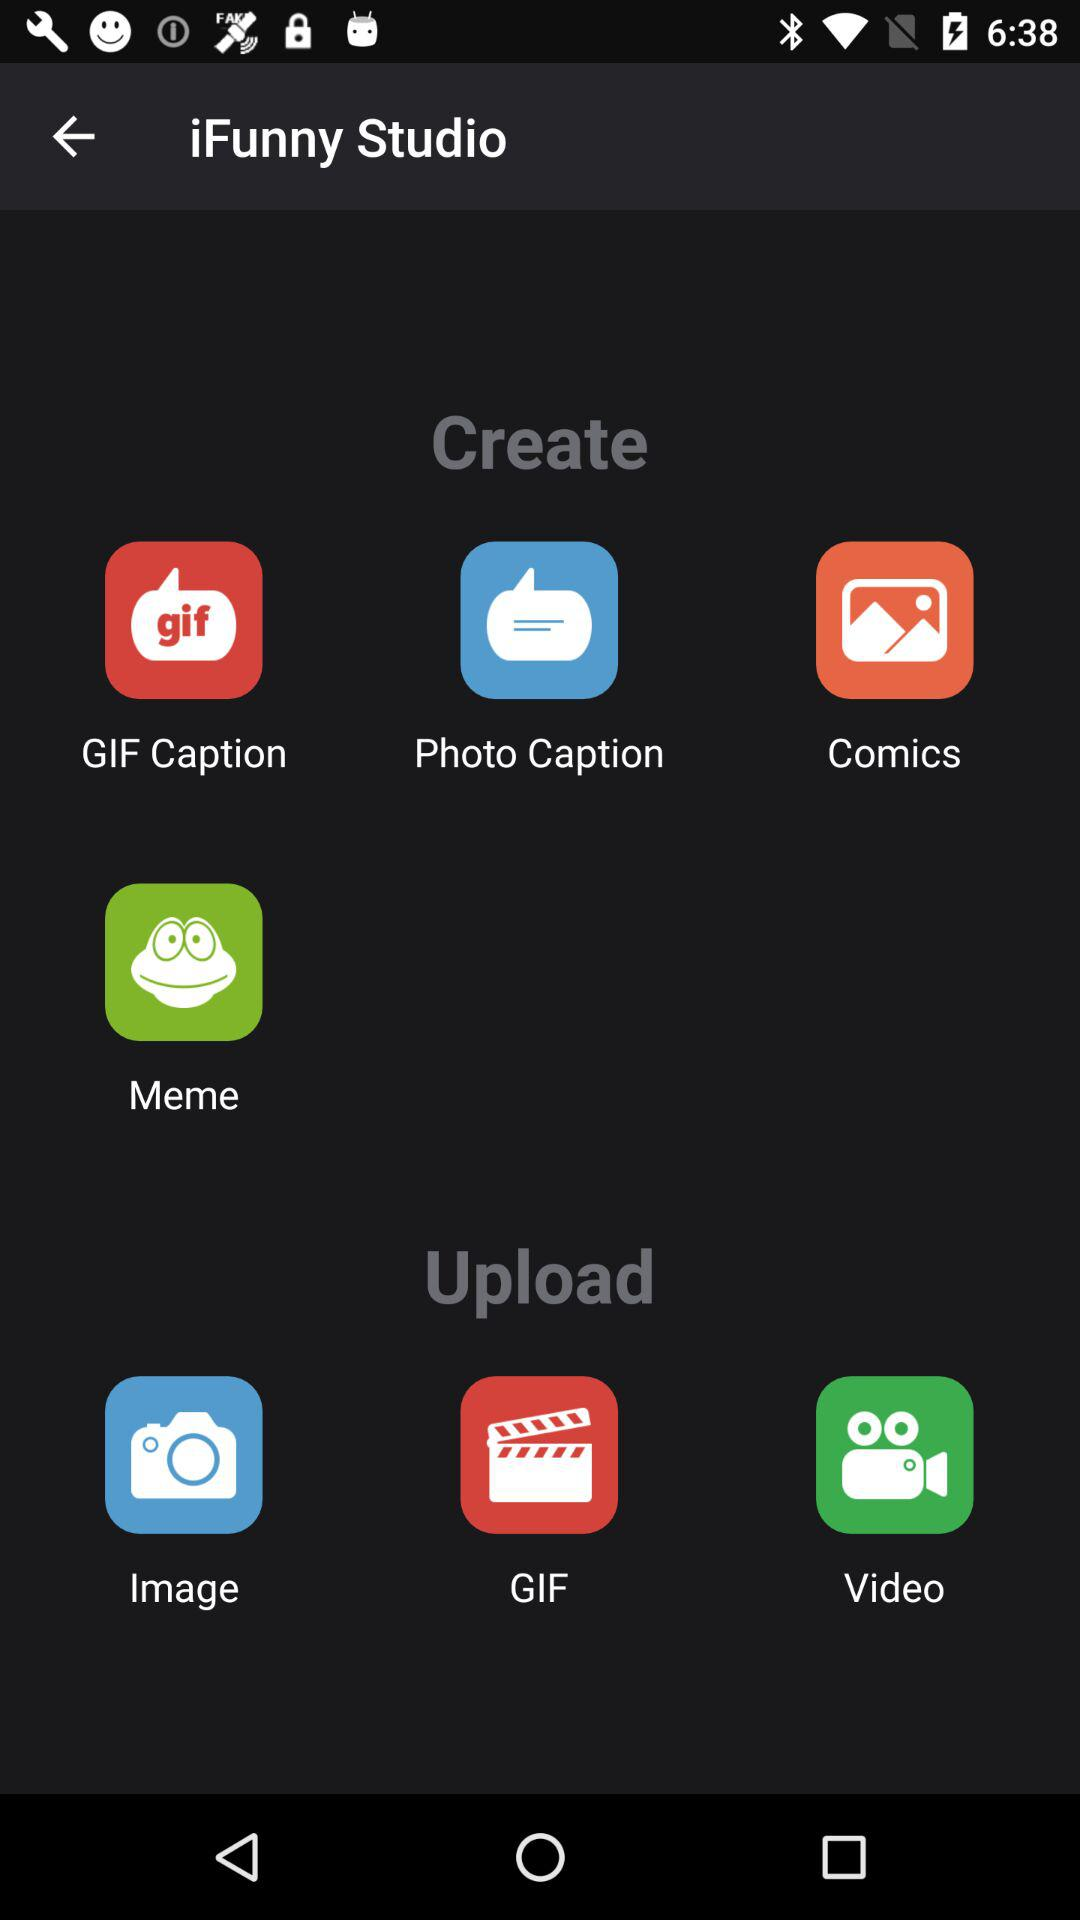What options are available in the "Create"? The available options in the "Create" are "GIF Caption", "Photo Caption", "Comics" and "Meme". 